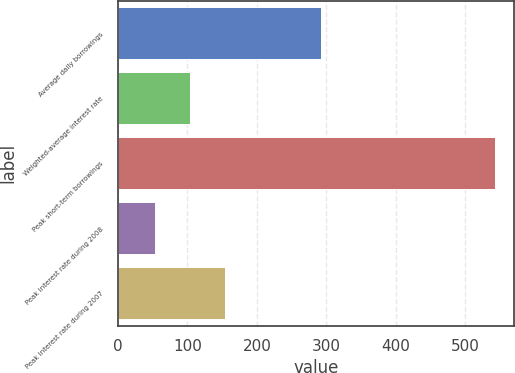Convert chart. <chart><loc_0><loc_0><loc_500><loc_500><bar_chart><fcel>Average daily borrowings<fcel>Weighted-average interest rate<fcel>Peak short-term borrowings<fcel>Peak interest rate during 2008<fcel>Peak interest rate during 2007<nl><fcel>292<fcel>103.81<fcel>543.27<fcel>53.53<fcel>154.09<nl></chart> 